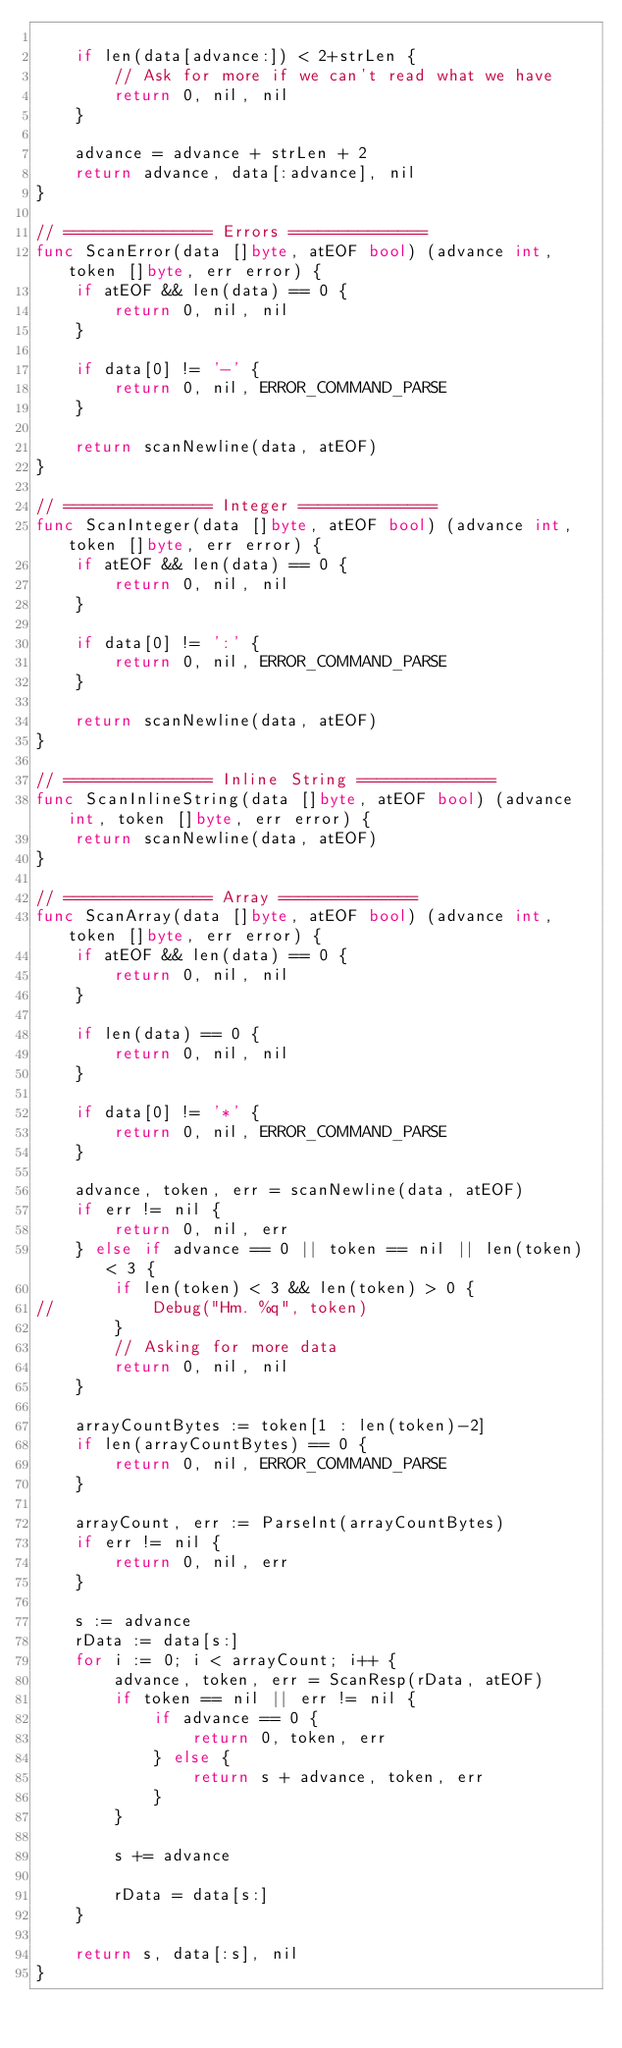Convert code to text. <code><loc_0><loc_0><loc_500><loc_500><_Go_>
	if len(data[advance:]) < 2+strLen {
		// Ask for more if we can't read what we have
		return 0, nil, nil
	}

	advance = advance + strLen + 2
	return advance, data[:advance], nil
}

// =============== Errors ==============
func ScanError(data []byte, atEOF bool) (advance int, token []byte, err error) {
	if atEOF && len(data) == 0 {
		return 0, nil, nil
	}

	if data[0] != '-' {
		return 0, nil, ERROR_COMMAND_PARSE
	}

	return scanNewline(data, atEOF)
}

// =============== Integer ==============
func ScanInteger(data []byte, atEOF bool) (advance int, token []byte, err error) {
	if atEOF && len(data) == 0 {
		return 0, nil, nil
	}

	if data[0] != ':' {
		return 0, nil, ERROR_COMMAND_PARSE
	}

	return scanNewline(data, atEOF)
}

// =============== Inline String ==============
func ScanInlineString(data []byte, atEOF bool) (advance int, token []byte, err error) {
	return scanNewline(data, atEOF)
}

// =============== Array ==============
func ScanArray(data []byte, atEOF bool) (advance int, token []byte, err error) {
	if atEOF && len(data) == 0 {
		return 0, nil, nil
	}

	if len(data) == 0 {
		return 0, nil, nil
	}

	if data[0] != '*' {
		return 0, nil, ERROR_COMMAND_PARSE
	}

	advance, token, err = scanNewline(data, atEOF)
	if err != nil {
		return 0, nil, err
	} else if advance == 0 || token == nil || len(token) < 3 {
		if len(token) < 3 && len(token) > 0 {
//			Debug("Hm. %q", token)
		}
		// Asking for more data
		return 0, nil, nil
	}

	arrayCountBytes := token[1 : len(token)-2]
	if len(arrayCountBytes) == 0 {
		return 0, nil, ERROR_COMMAND_PARSE
	}

	arrayCount, err := ParseInt(arrayCountBytes)
	if err != nil {
		return 0, nil, err
	}

	s := advance
	rData := data[s:]
	for i := 0; i < arrayCount; i++ {
		advance, token, err = ScanResp(rData, atEOF)
		if token == nil || err != nil {
			if advance == 0 {
				return 0, token, err
			} else {
				return s + advance, token, err
			}
		}

		s += advance

		rData = data[s:]
	}

	return s, data[:s], nil
}

</code> 